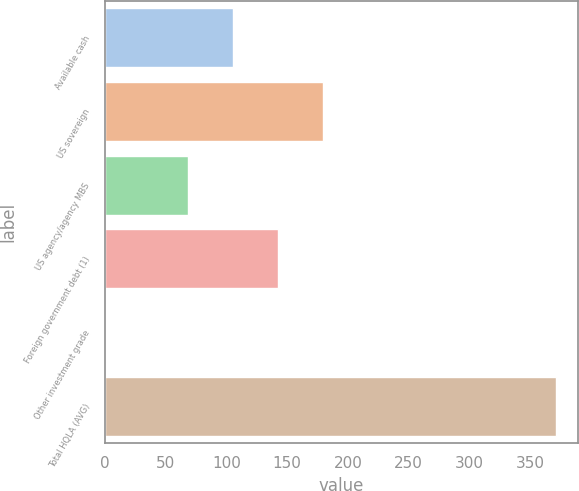Convert chart. <chart><loc_0><loc_0><loc_500><loc_500><bar_chart><fcel>Available cash<fcel>US sovereign<fcel>US agency/agency MBS<fcel>Foreign government debt (1)<fcel>Other investment grade<fcel>Total HQLA (AVG)<nl><fcel>105.15<fcel>179.25<fcel>68.1<fcel>142.2<fcel>0.5<fcel>371<nl></chart> 